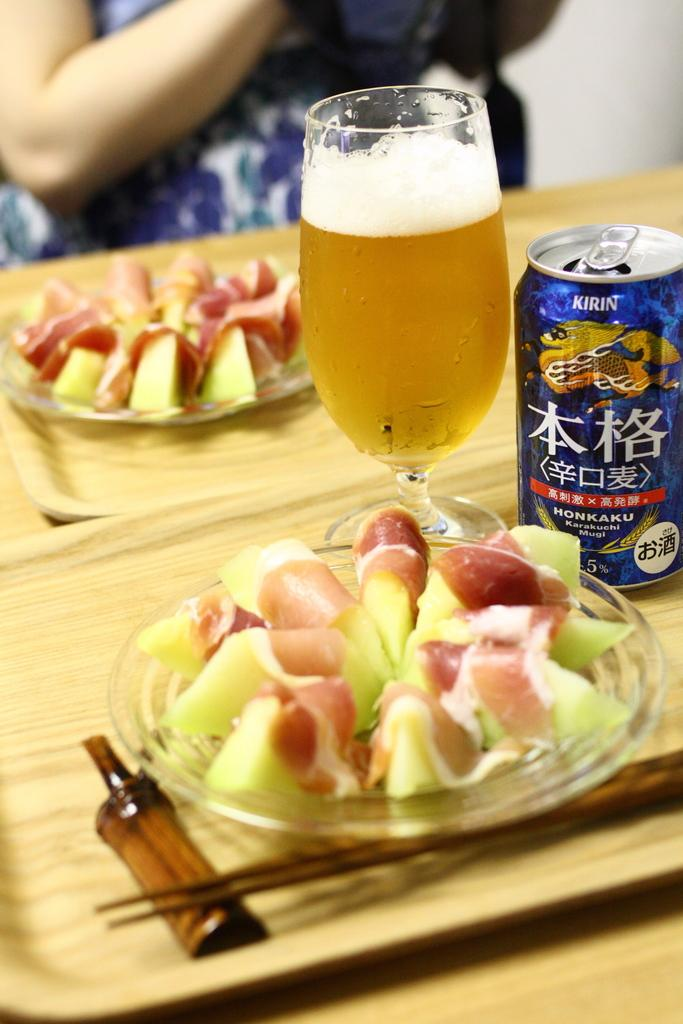How many plates of food items can be seen in the image? There are two plates of food items in the image. What type of containers are the food items placed in? The food items are in trays. What type of beverage container is present in the image? There is a glass in the image. What type of can is present in the image? There is a can in the image. What utensils are present in the image? Chopsticks are present in the image. Can you describe the person in the image? A person is sitting behind the items, but their appearance cannot be determined from the image. How many grapes are on the wheel in the image? There are no grapes or wheels present in the image. What type of relationship does the person in the image have with the father? The image does not provide any information about the person's relationship with a father, as it only shows a person sitting behind the items. 